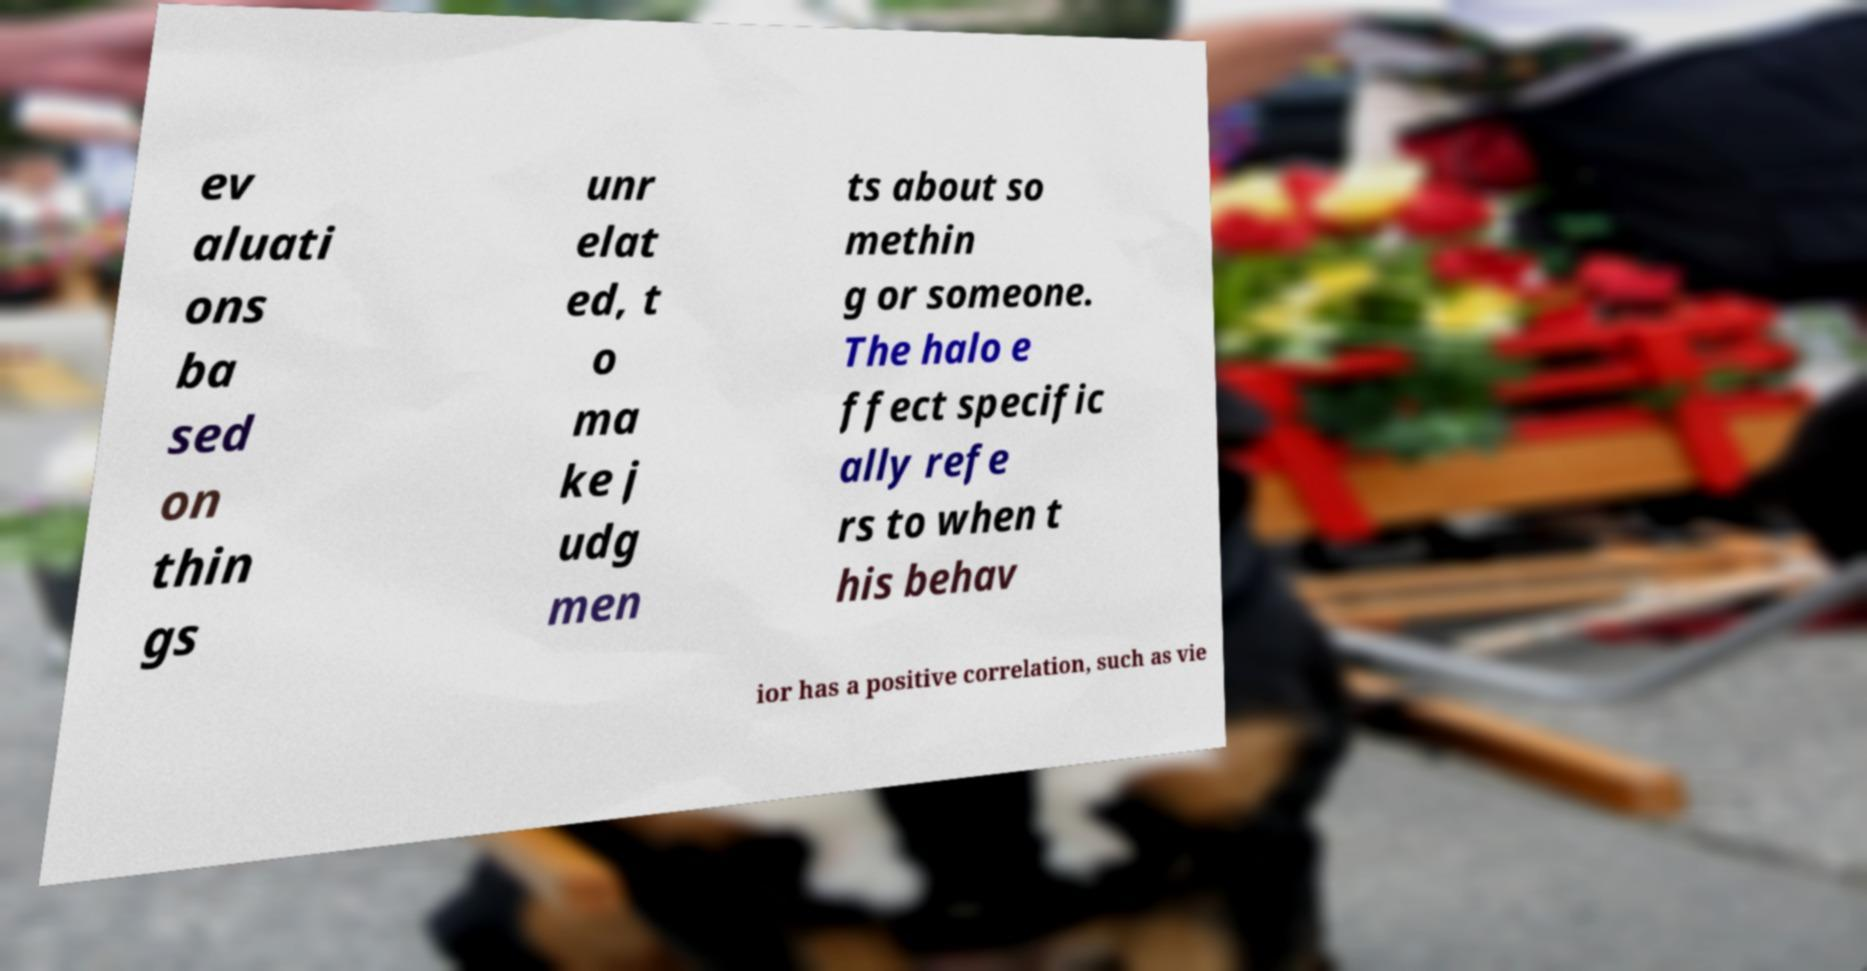What messages or text are displayed in this image? I need them in a readable, typed format. ev aluati ons ba sed on thin gs unr elat ed, t o ma ke j udg men ts about so methin g or someone. The halo e ffect specific ally refe rs to when t his behav ior has a positive correlation, such as vie 